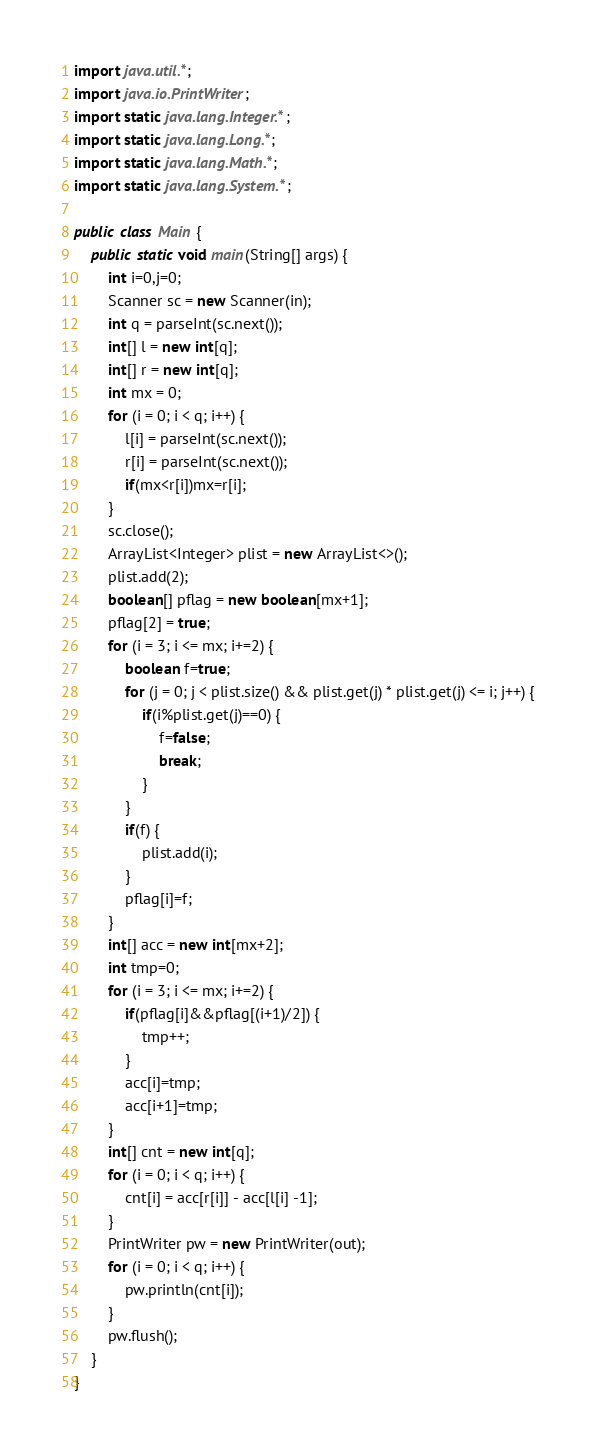<code> <loc_0><loc_0><loc_500><loc_500><_Java_>import java.util.*;
import java.io.PrintWriter;
import static java.lang.Integer.*;
import static java.lang.Long.*;
import static java.lang.Math.*;
import static java.lang.System.*;

public class Main {
	public static void main(String[] args) {
		int i=0,j=0;
		Scanner sc = new Scanner(in);
		int q = parseInt(sc.next());
		int[] l = new int[q];
		int[] r = new int[q];
		int mx = 0;
		for (i = 0; i < q; i++) {
			l[i] = parseInt(sc.next());
			r[i] = parseInt(sc.next());
			if(mx<r[i])mx=r[i];
		}
		sc.close();
		ArrayList<Integer> plist = new ArrayList<>(); 
		plist.add(2);
		boolean[] pflag = new boolean[mx+1];
		pflag[2] = true;
		for (i = 3; i <= mx; i+=2) {
			boolean f=true;
			for (j = 0; j < plist.size() && plist.get(j) * plist.get(j) <= i; j++) {
				if(i%plist.get(j)==0) {
					f=false;
					break;
				}
			}
			if(f) {
				plist.add(i);
			}
			pflag[i]=f;
		}
		int[] acc = new int[mx+2];
		int tmp=0;
		for (i = 3; i <= mx; i+=2) {
			if(pflag[i]&&pflag[(i+1)/2]) {
				tmp++;
			}
			acc[i]=tmp;
			acc[i+1]=tmp;
		}
		int[] cnt = new int[q];
		for (i = 0; i < q; i++) {
			cnt[i] = acc[r[i]] - acc[l[i] -1];
		}
		PrintWriter pw = new PrintWriter(out);
		for (i = 0; i < q; i++) {
			pw.println(cnt[i]);
		}
		pw.flush();
	}
}
</code> 